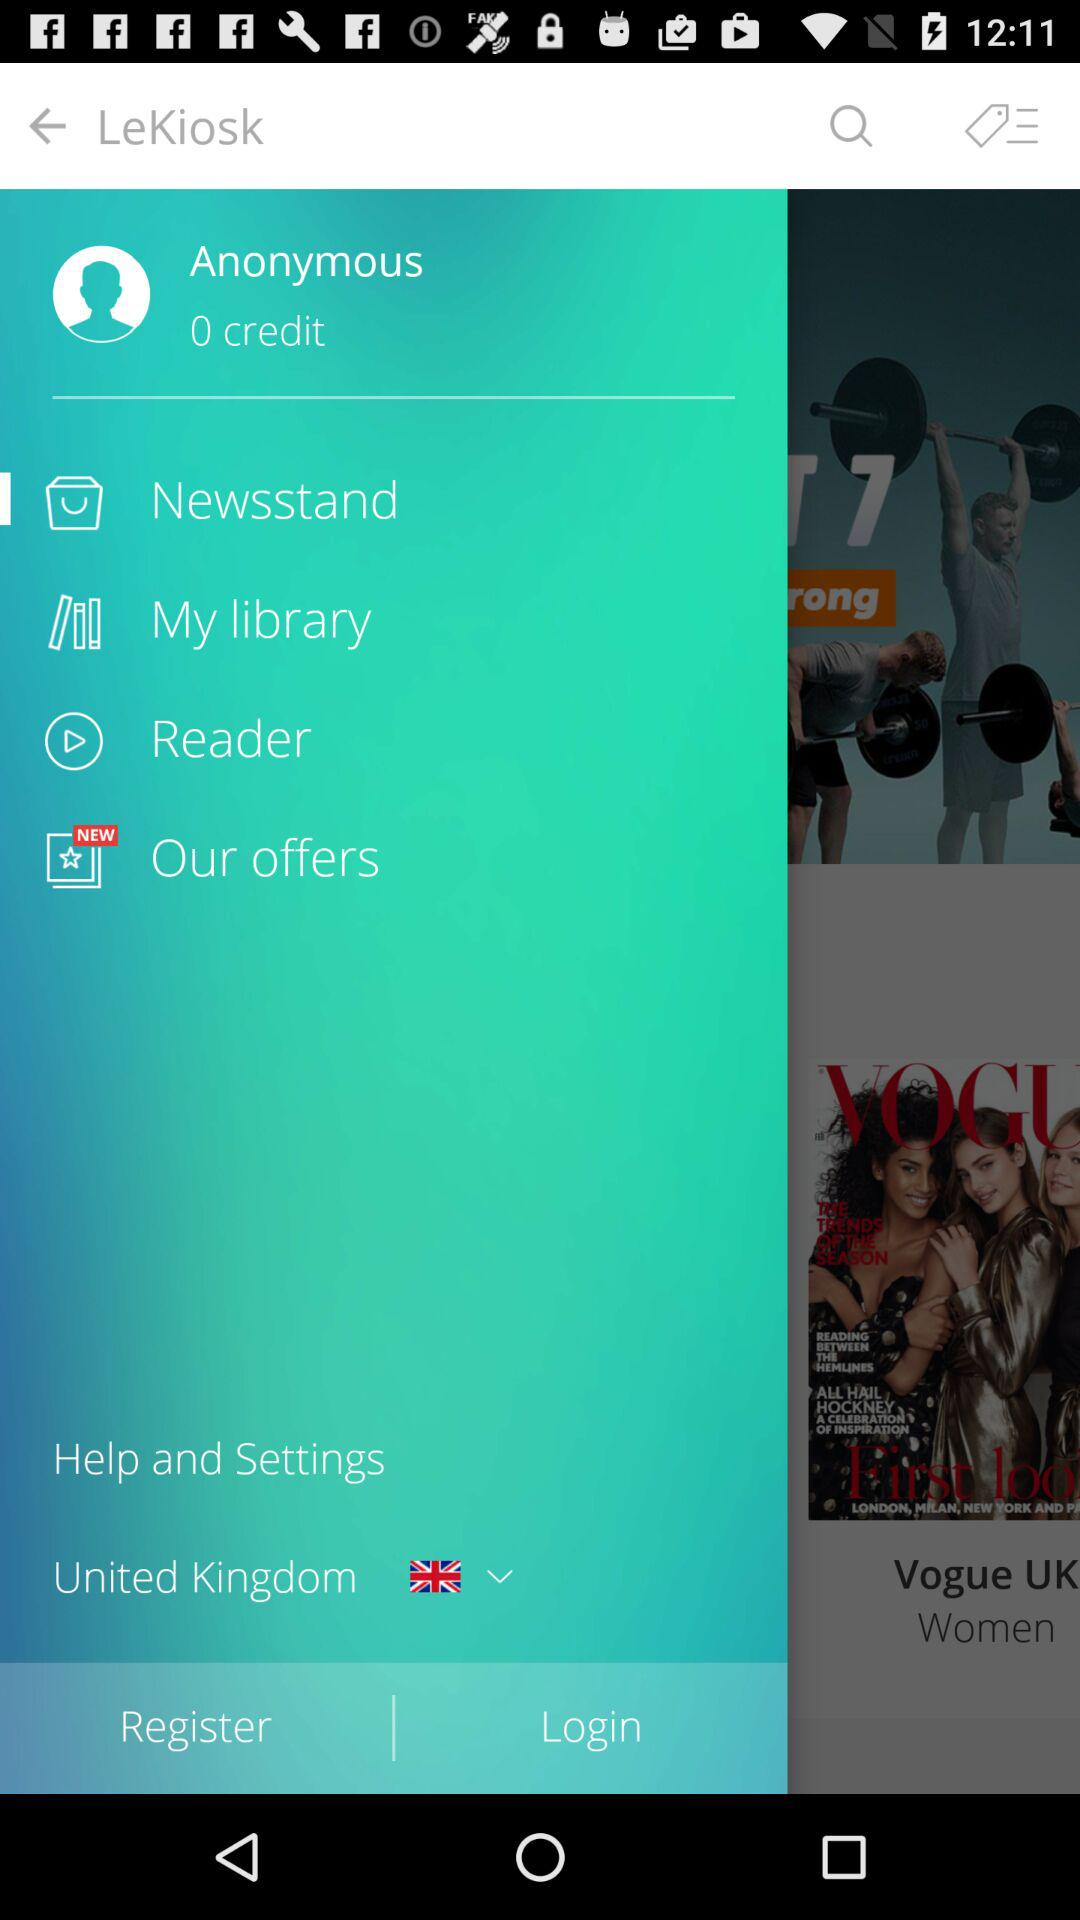How many credits are there? There are 0 credits. 